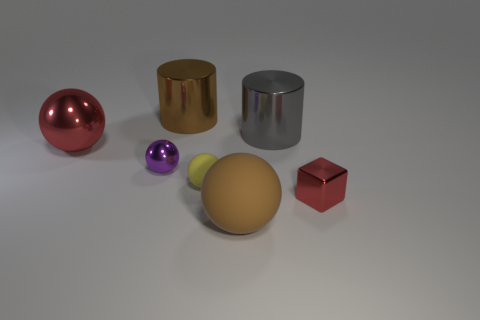Add 1 gray cylinders. How many objects exist? 8 Subtract all cubes. How many objects are left? 6 Add 7 small yellow things. How many small yellow things exist? 8 Subtract 0 green cylinders. How many objects are left? 7 Subtract all small red metal things. Subtract all large brown shiny objects. How many objects are left? 5 Add 6 big gray shiny things. How many big gray shiny things are left? 7 